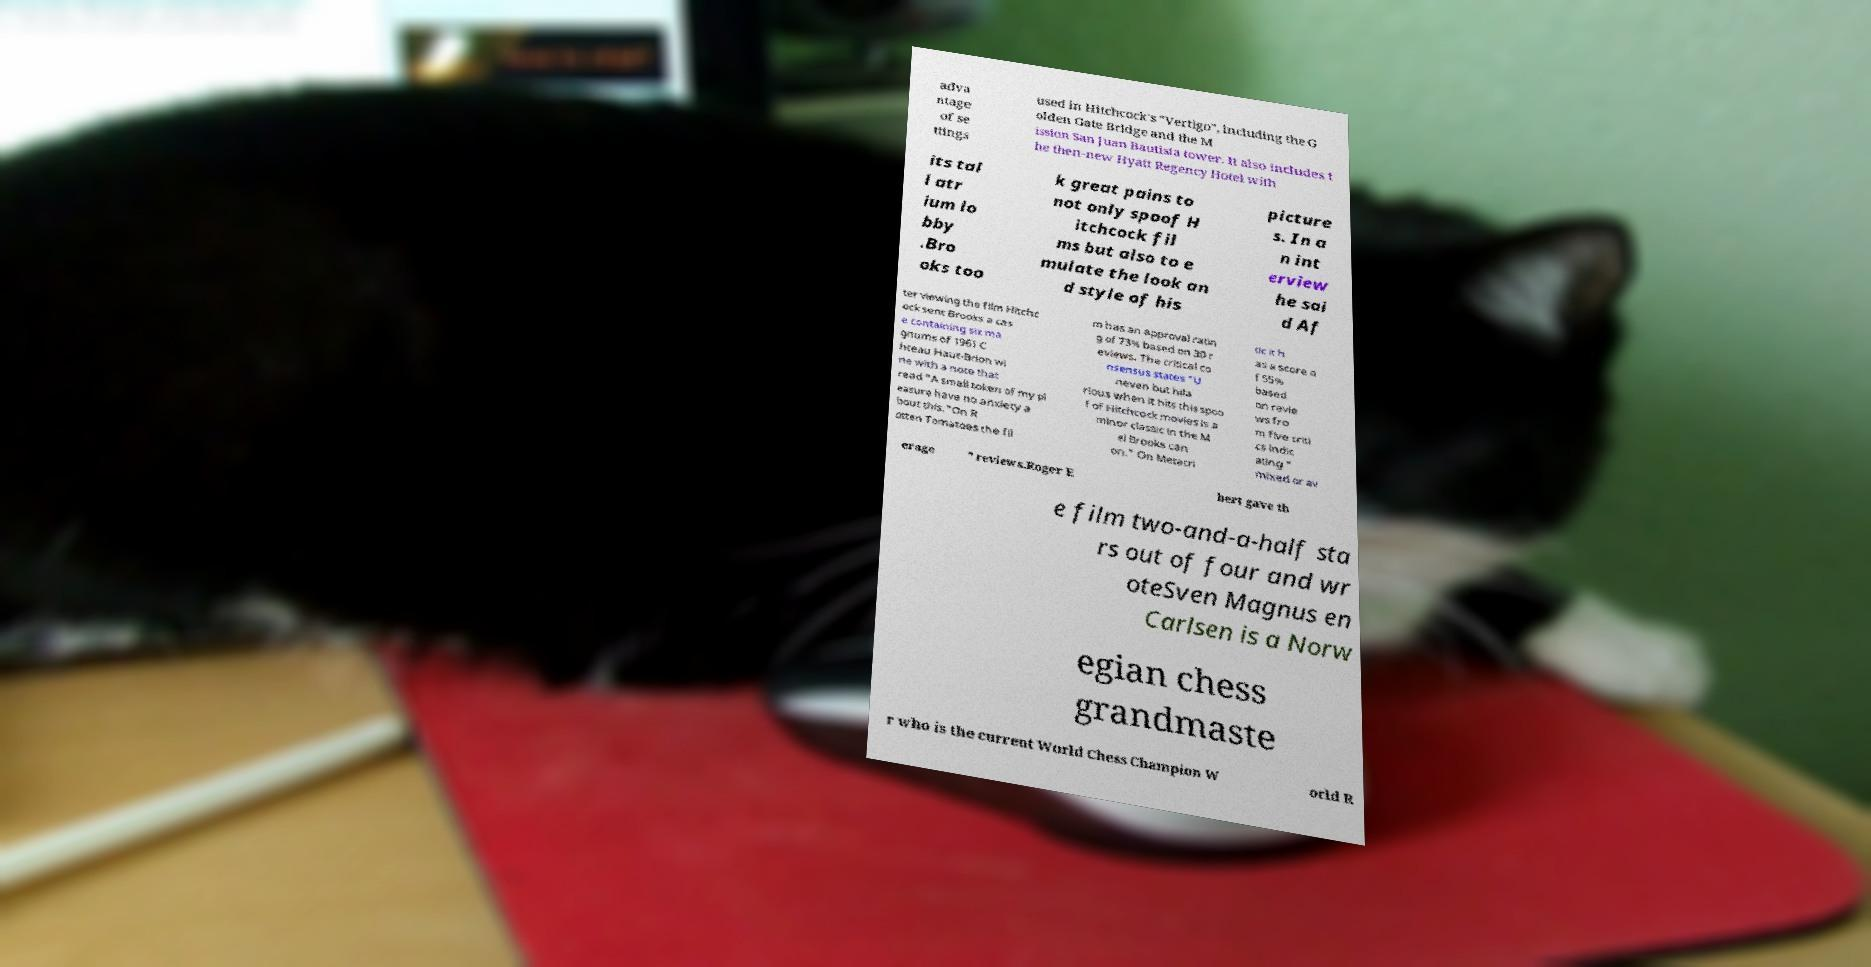Can you accurately transcribe the text from the provided image for me? adva ntage of se ttings used in Hitchcock's "Vertigo", including the G olden Gate Bridge and the M ission San Juan Bautista tower. It also includes t he then-new Hyatt Regency Hotel with its tal l atr ium lo bby .Bro oks too k great pains to not only spoof H itchcock fil ms but also to e mulate the look an d style of his picture s. In a n int erview he sai d Af ter viewing the film Hitchc ock sent Brooks a cas e containing six ma gnums of 1961 C hteau Haut-Brion wi ne with a note that read "A small token of my pl easure have no anxiety a bout this."On R otten Tomatoes the fil m has an approval ratin g of 73% based on 30 r eviews. The critical co nsensus states "U neven but hila rious when it hits this spoo f of Hitchcock movies is a minor classic in the M el Brooks can on." On Metacri tic it h as a score o f 55% based on revie ws fro m five criti cs indic ating " mixed or av erage " reviews.Roger E bert gave th e film two-and-a-half sta rs out of four and wr oteSven Magnus en Carlsen is a Norw egian chess grandmaste r who is the current World Chess Champion W orld R 